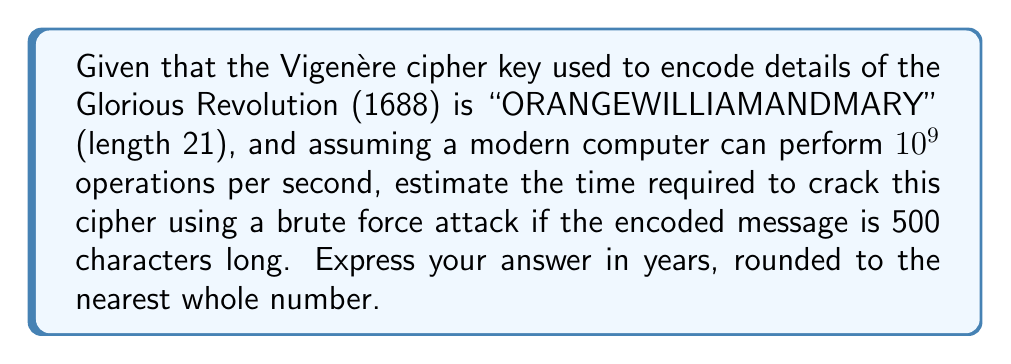Can you solve this math problem? To solve this problem, we need to follow these steps:

1) First, calculate the total number of possible keys:
   There are 26 possible letters for each position in the key.
   The key length is 21.
   So, the total number of possible keys is $26^{21}$.

2) Calculate the number of operations needed:
   $$26^{21} = 2.64 \times 10^{29}$$ operations

3) Calculate the time needed in seconds:
   Time = Number of operations / Operations per second
   $$T = \frac{2.64 \times 10^{29}}{10^9} = 2.64 \times 10^{20}$$ seconds

4) Convert seconds to years:
   1 year = 365.25 days = 365.25 * 24 * 60 * 60 = 31,557,600 seconds
   
   Years = $\frac{2.64 \times 10^{20}}{31,557,600} = 8.37 \times 10^{12}$ years

5) Round to the nearest whole number:
   8,370,000,000,000 years

Note: This calculation assumes a brute force attack. In practice, more sophisticated methods like the Kasiski examination or index of coincidence could be used to crack the cipher much faster, especially given the historical context and potential known plaintext.
Answer: 8,370,000,000,000 years 